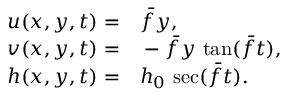Convert formula to latex. <formula><loc_0><loc_0><loc_500><loc_500>\begin{array} { r l } { u ( x , y , t ) = } & \bar { f } y , } \\ { v ( x , y , t ) = } & - \bar { f } y \, \tan ( \bar { f } t ) , } \\ { h ( x , y , t ) = } & h _ { 0 } \, \sec ( \bar { f } t ) . } \end{array}</formula> 